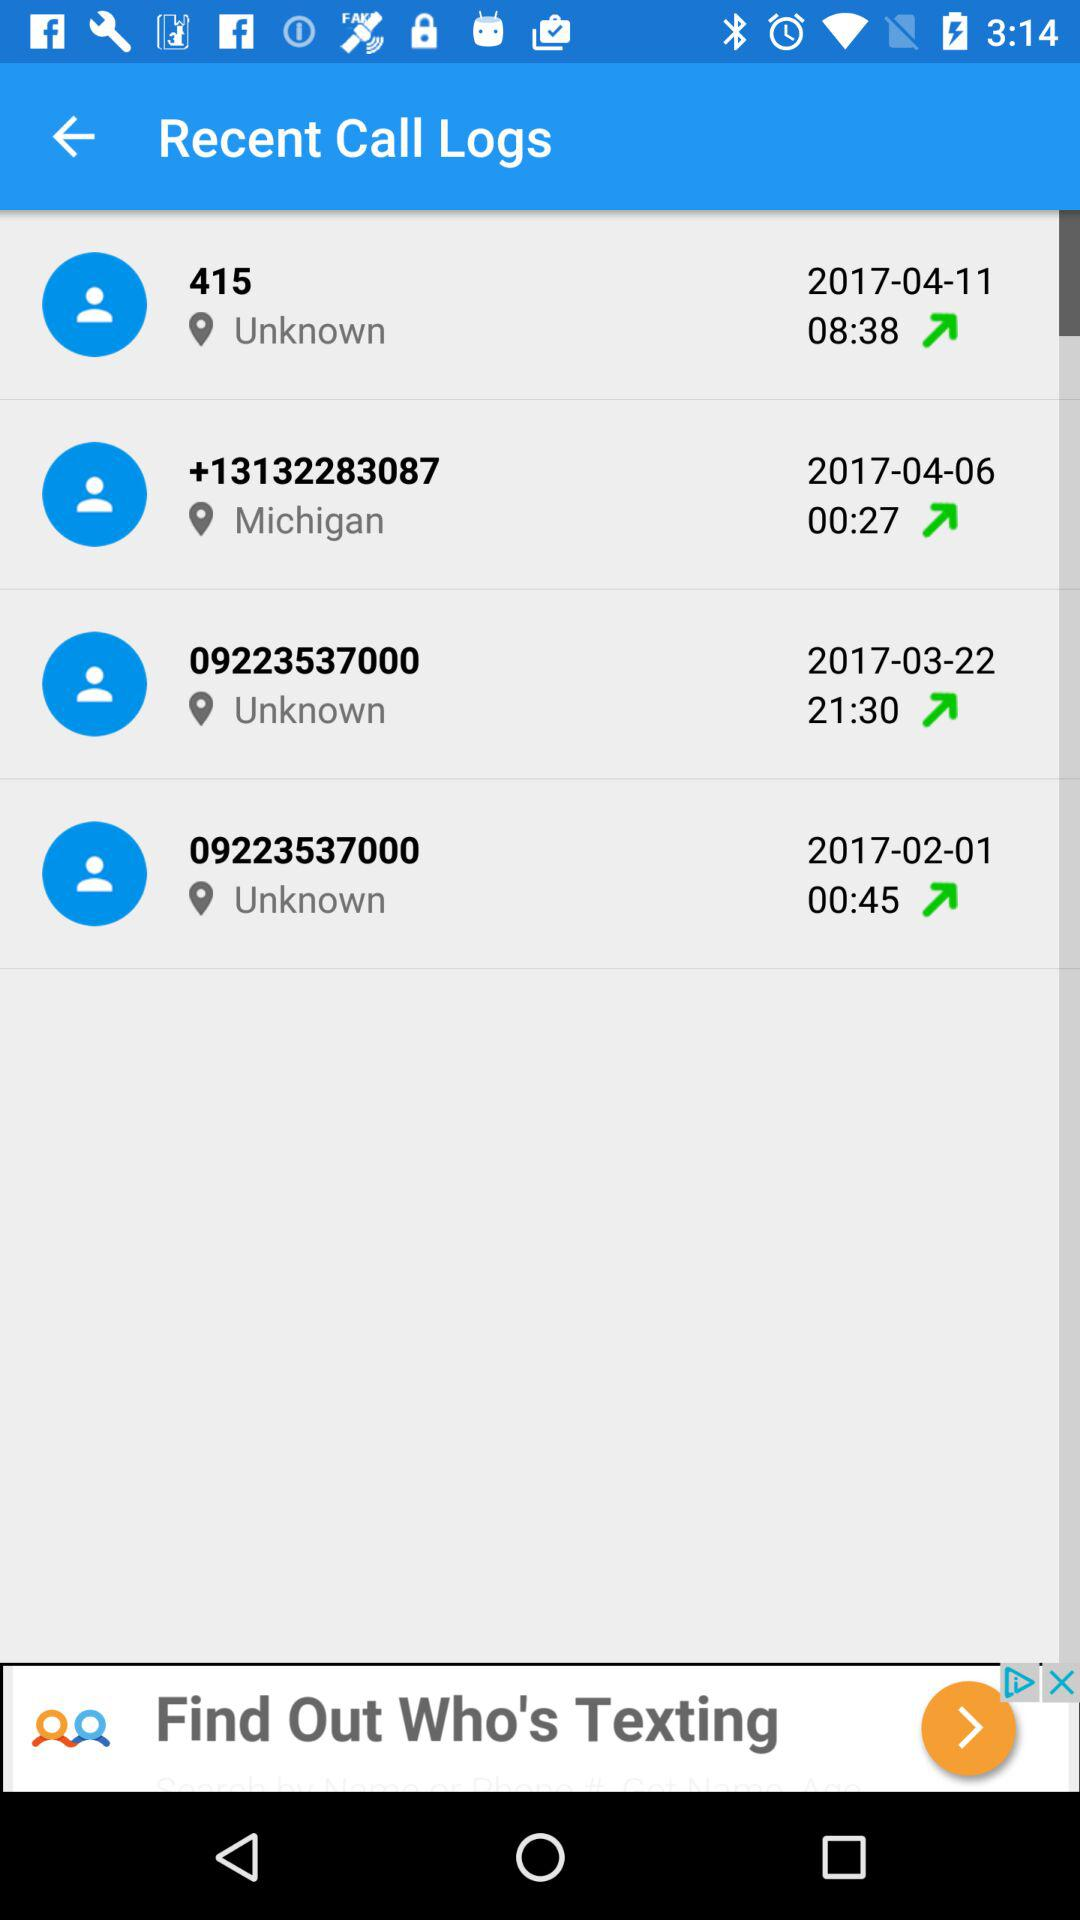Are the times shown on the screen AM or PM?
When the provided information is insufficient, respond with <no answer>. <no answer> 